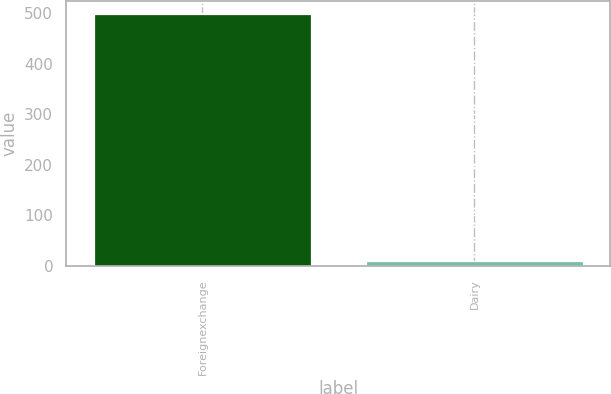<chart> <loc_0><loc_0><loc_500><loc_500><bar_chart><fcel>Foreignexchange<fcel>Dairy<nl><fcel>499<fcel>10<nl></chart> 